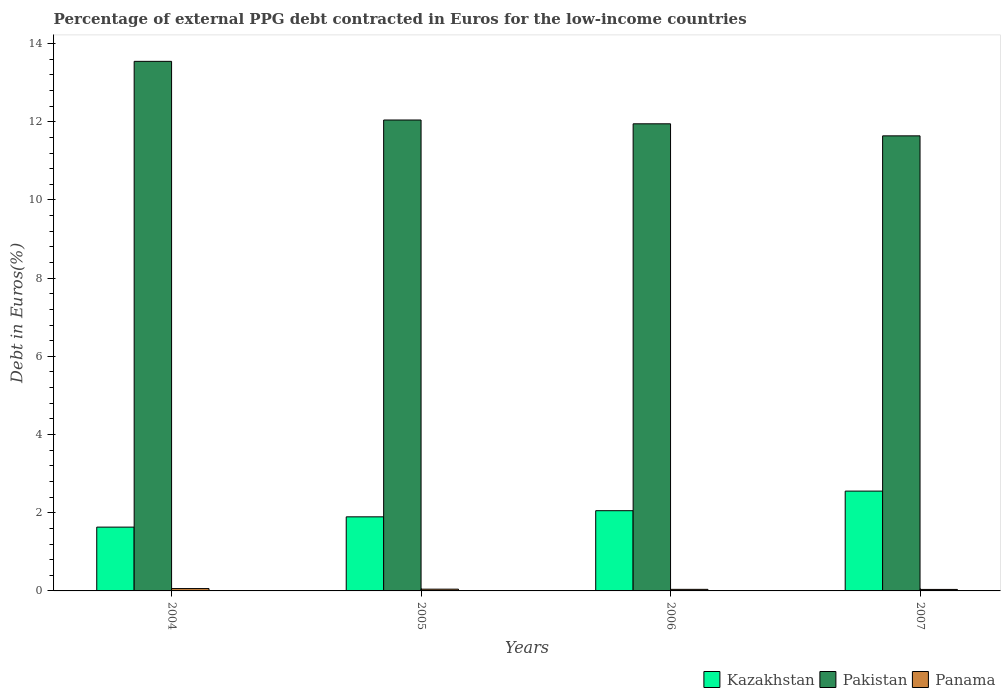How many groups of bars are there?
Provide a succinct answer. 4. Are the number of bars per tick equal to the number of legend labels?
Ensure brevity in your answer.  Yes. What is the label of the 4th group of bars from the left?
Keep it short and to the point. 2007. In how many cases, is the number of bars for a given year not equal to the number of legend labels?
Your answer should be very brief. 0. What is the percentage of external PPG debt contracted in Euros in Panama in 2004?
Your answer should be very brief. 0.06. Across all years, what is the maximum percentage of external PPG debt contracted in Euros in Panama?
Your response must be concise. 0.06. Across all years, what is the minimum percentage of external PPG debt contracted in Euros in Panama?
Provide a short and direct response. 0.04. What is the total percentage of external PPG debt contracted in Euros in Kazakhstan in the graph?
Keep it short and to the point. 8.13. What is the difference between the percentage of external PPG debt contracted in Euros in Kazakhstan in 2005 and that in 2006?
Offer a terse response. -0.16. What is the difference between the percentage of external PPG debt contracted in Euros in Panama in 2007 and the percentage of external PPG debt contracted in Euros in Kazakhstan in 2006?
Your response must be concise. -2.01. What is the average percentage of external PPG debt contracted in Euros in Kazakhstan per year?
Your response must be concise. 2.03. In the year 2005, what is the difference between the percentage of external PPG debt contracted in Euros in Kazakhstan and percentage of external PPG debt contracted in Euros in Pakistan?
Your response must be concise. -10.15. In how many years, is the percentage of external PPG debt contracted in Euros in Panama greater than 6.4 %?
Keep it short and to the point. 0. What is the ratio of the percentage of external PPG debt contracted in Euros in Panama in 2006 to that in 2007?
Offer a terse response. 1.05. What is the difference between the highest and the second highest percentage of external PPG debt contracted in Euros in Panama?
Give a very brief answer. 0.02. What is the difference between the highest and the lowest percentage of external PPG debt contracted in Euros in Kazakhstan?
Provide a short and direct response. 0.92. What does the 1st bar from the left in 2007 represents?
Ensure brevity in your answer.  Kazakhstan. What does the 3rd bar from the right in 2007 represents?
Provide a short and direct response. Kazakhstan. Are all the bars in the graph horizontal?
Ensure brevity in your answer.  No. How many years are there in the graph?
Ensure brevity in your answer.  4. Does the graph contain any zero values?
Your response must be concise. No. Where does the legend appear in the graph?
Your response must be concise. Bottom right. What is the title of the graph?
Your answer should be compact. Percentage of external PPG debt contracted in Euros for the low-income countries. What is the label or title of the Y-axis?
Your answer should be very brief. Debt in Euros(%). What is the Debt in Euros(%) in Kazakhstan in 2004?
Your answer should be compact. 1.63. What is the Debt in Euros(%) of Pakistan in 2004?
Provide a succinct answer. 13.54. What is the Debt in Euros(%) in Panama in 2004?
Make the answer very short. 0.06. What is the Debt in Euros(%) of Kazakhstan in 2005?
Ensure brevity in your answer.  1.89. What is the Debt in Euros(%) of Pakistan in 2005?
Ensure brevity in your answer.  12.04. What is the Debt in Euros(%) in Panama in 2005?
Offer a terse response. 0.04. What is the Debt in Euros(%) in Kazakhstan in 2006?
Provide a succinct answer. 2.05. What is the Debt in Euros(%) in Pakistan in 2006?
Your response must be concise. 11.95. What is the Debt in Euros(%) of Panama in 2006?
Ensure brevity in your answer.  0.04. What is the Debt in Euros(%) of Kazakhstan in 2007?
Provide a succinct answer. 2.55. What is the Debt in Euros(%) of Pakistan in 2007?
Give a very brief answer. 11.64. What is the Debt in Euros(%) of Panama in 2007?
Offer a terse response. 0.04. Across all years, what is the maximum Debt in Euros(%) in Kazakhstan?
Your response must be concise. 2.55. Across all years, what is the maximum Debt in Euros(%) in Pakistan?
Your answer should be compact. 13.54. Across all years, what is the maximum Debt in Euros(%) of Panama?
Ensure brevity in your answer.  0.06. Across all years, what is the minimum Debt in Euros(%) of Kazakhstan?
Provide a short and direct response. 1.63. Across all years, what is the minimum Debt in Euros(%) of Pakistan?
Provide a succinct answer. 11.64. Across all years, what is the minimum Debt in Euros(%) of Panama?
Make the answer very short. 0.04. What is the total Debt in Euros(%) of Kazakhstan in the graph?
Your answer should be compact. 8.13. What is the total Debt in Euros(%) in Pakistan in the graph?
Make the answer very short. 49.17. What is the total Debt in Euros(%) of Panama in the graph?
Your answer should be compact. 0.18. What is the difference between the Debt in Euros(%) of Kazakhstan in 2004 and that in 2005?
Provide a succinct answer. -0.26. What is the difference between the Debt in Euros(%) of Pakistan in 2004 and that in 2005?
Offer a terse response. 1.5. What is the difference between the Debt in Euros(%) in Panama in 2004 and that in 2005?
Make the answer very short. 0.02. What is the difference between the Debt in Euros(%) in Kazakhstan in 2004 and that in 2006?
Provide a succinct answer. -0.42. What is the difference between the Debt in Euros(%) of Pakistan in 2004 and that in 2006?
Offer a very short reply. 1.6. What is the difference between the Debt in Euros(%) in Panama in 2004 and that in 2006?
Offer a terse response. 0.02. What is the difference between the Debt in Euros(%) of Kazakhstan in 2004 and that in 2007?
Your answer should be very brief. -0.92. What is the difference between the Debt in Euros(%) in Pakistan in 2004 and that in 2007?
Provide a short and direct response. 1.91. What is the difference between the Debt in Euros(%) of Panama in 2004 and that in 2007?
Give a very brief answer. 0.02. What is the difference between the Debt in Euros(%) in Kazakhstan in 2005 and that in 2006?
Keep it short and to the point. -0.16. What is the difference between the Debt in Euros(%) in Pakistan in 2005 and that in 2006?
Your answer should be compact. 0.1. What is the difference between the Debt in Euros(%) of Panama in 2005 and that in 2006?
Provide a succinct answer. 0. What is the difference between the Debt in Euros(%) in Kazakhstan in 2005 and that in 2007?
Provide a short and direct response. -0.66. What is the difference between the Debt in Euros(%) in Pakistan in 2005 and that in 2007?
Provide a succinct answer. 0.41. What is the difference between the Debt in Euros(%) in Panama in 2005 and that in 2007?
Provide a short and direct response. 0.01. What is the difference between the Debt in Euros(%) of Kazakhstan in 2006 and that in 2007?
Offer a terse response. -0.5. What is the difference between the Debt in Euros(%) in Pakistan in 2006 and that in 2007?
Provide a succinct answer. 0.31. What is the difference between the Debt in Euros(%) in Panama in 2006 and that in 2007?
Make the answer very short. 0. What is the difference between the Debt in Euros(%) in Kazakhstan in 2004 and the Debt in Euros(%) in Pakistan in 2005?
Give a very brief answer. -10.41. What is the difference between the Debt in Euros(%) in Kazakhstan in 2004 and the Debt in Euros(%) in Panama in 2005?
Ensure brevity in your answer.  1.59. What is the difference between the Debt in Euros(%) in Pakistan in 2004 and the Debt in Euros(%) in Panama in 2005?
Your response must be concise. 13.5. What is the difference between the Debt in Euros(%) of Kazakhstan in 2004 and the Debt in Euros(%) of Pakistan in 2006?
Give a very brief answer. -10.32. What is the difference between the Debt in Euros(%) in Kazakhstan in 2004 and the Debt in Euros(%) in Panama in 2006?
Your answer should be very brief. 1.59. What is the difference between the Debt in Euros(%) of Pakistan in 2004 and the Debt in Euros(%) of Panama in 2006?
Your response must be concise. 13.5. What is the difference between the Debt in Euros(%) in Kazakhstan in 2004 and the Debt in Euros(%) in Pakistan in 2007?
Provide a short and direct response. -10.01. What is the difference between the Debt in Euros(%) in Kazakhstan in 2004 and the Debt in Euros(%) in Panama in 2007?
Give a very brief answer. 1.59. What is the difference between the Debt in Euros(%) of Pakistan in 2004 and the Debt in Euros(%) of Panama in 2007?
Your answer should be compact. 13.51. What is the difference between the Debt in Euros(%) of Kazakhstan in 2005 and the Debt in Euros(%) of Pakistan in 2006?
Your answer should be very brief. -10.05. What is the difference between the Debt in Euros(%) in Kazakhstan in 2005 and the Debt in Euros(%) in Panama in 2006?
Give a very brief answer. 1.85. What is the difference between the Debt in Euros(%) in Pakistan in 2005 and the Debt in Euros(%) in Panama in 2006?
Provide a succinct answer. 12. What is the difference between the Debt in Euros(%) in Kazakhstan in 2005 and the Debt in Euros(%) in Pakistan in 2007?
Your answer should be very brief. -9.74. What is the difference between the Debt in Euros(%) of Kazakhstan in 2005 and the Debt in Euros(%) of Panama in 2007?
Ensure brevity in your answer.  1.86. What is the difference between the Debt in Euros(%) of Pakistan in 2005 and the Debt in Euros(%) of Panama in 2007?
Keep it short and to the point. 12.01. What is the difference between the Debt in Euros(%) of Kazakhstan in 2006 and the Debt in Euros(%) of Pakistan in 2007?
Your response must be concise. -9.59. What is the difference between the Debt in Euros(%) in Kazakhstan in 2006 and the Debt in Euros(%) in Panama in 2007?
Offer a terse response. 2.01. What is the difference between the Debt in Euros(%) in Pakistan in 2006 and the Debt in Euros(%) in Panama in 2007?
Your answer should be very brief. 11.91. What is the average Debt in Euros(%) of Kazakhstan per year?
Give a very brief answer. 2.03. What is the average Debt in Euros(%) in Pakistan per year?
Offer a very short reply. 12.29. What is the average Debt in Euros(%) of Panama per year?
Provide a succinct answer. 0.05. In the year 2004, what is the difference between the Debt in Euros(%) of Kazakhstan and Debt in Euros(%) of Pakistan?
Ensure brevity in your answer.  -11.91. In the year 2004, what is the difference between the Debt in Euros(%) of Kazakhstan and Debt in Euros(%) of Panama?
Ensure brevity in your answer.  1.57. In the year 2004, what is the difference between the Debt in Euros(%) in Pakistan and Debt in Euros(%) in Panama?
Ensure brevity in your answer.  13.48. In the year 2005, what is the difference between the Debt in Euros(%) in Kazakhstan and Debt in Euros(%) in Pakistan?
Ensure brevity in your answer.  -10.15. In the year 2005, what is the difference between the Debt in Euros(%) of Kazakhstan and Debt in Euros(%) of Panama?
Provide a short and direct response. 1.85. In the year 2005, what is the difference between the Debt in Euros(%) of Pakistan and Debt in Euros(%) of Panama?
Provide a short and direct response. 12. In the year 2006, what is the difference between the Debt in Euros(%) of Kazakhstan and Debt in Euros(%) of Pakistan?
Make the answer very short. -9.9. In the year 2006, what is the difference between the Debt in Euros(%) of Kazakhstan and Debt in Euros(%) of Panama?
Offer a terse response. 2.01. In the year 2006, what is the difference between the Debt in Euros(%) in Pakistan and Debt in Euros(%) in Panama?
Offer a very short reply. 11.91. In the year 2007, what is the difference between the Debt in Euros(%) of Kazakhstan and Debt in Euros(%) of Pakistan?
Provide a succinct answer. -9.09. In the year 2007, what is the difference between the Debt in Euros(%) of Kazakhstan and Debt in Euros(%) of Panama?
Provide a succinct answer. 2.51. In the year 2007, what is the difference between the Debt in Euros(%) of Pakistan and Debt in Euros(%) of Panama?
Offer a very short reply. 11.6. What is the ratio of the Debt in Euros(%) of Kazakhstan in 2004 to that in 2005?
Make the answer very short. 0.86. What is the ratio of the Debt in Euros(%) in Pakistan in 2004 to that in 2005?
Provide a short and direct response. 1.12. What is the ratio of the Debt in Euros(%) in Panama in 2004 to that in 2005?
Give a very brief answer. 1.34. What is the ratio of the Debt in Euros(%) in Kazakhstan in 2004 to that in 2006?
Give a very brief answer. 0.8. What is the ratio of the Debt in Euros(%) of Pakistan in 2004 to that in 2006?
Provide a short and direct response. 1.13. What is the ratio of the Debt in Euros(%) of Panama in 2004 to that in 2006?
Offer a very short reply. 1.5. What is the ratio of the Debt in Euros(%) of Kazakhstan in 2004 to that in 2007?
Give a very brief answer. 0.64. What is the ratio of the Debt in Euros(%) in Pakistan in 2004 to that in 2007?
Provide a short and direct response. 1.16. What is the ratio of the Debt in Euros(%) of Panama in 2004 to that in 2007?
Offer a terse response. 1.57. What is the ratio of the Debt in Euros(%) of Kazakhstan in 2005 to that in 2006?
Your response must be concise. 0.92. What is the ratio of the Debt in Euros(%) in Pakistan in 2005 to that in 2006?
Give a very brief answer. 1.01. What is the ratio of the Debt in Euros(%) of Panama in 2005 to that in 2006?
Offer a terse response. 1.12. What is the ratio of the Debt in Euros(%) in Kazakhstan in 2005 to that in 2007?
Provide a short and direct response. 0.74. What is the ratio of the Debt in Euros(%) in Pakistan in 2005 to that in 2007?
Ensure brevity in your answer.  1.03. What is the ratio of the Debt in Euros(%) of Panama in 2005 to that in 2007?
Make the answer very short. 1.17. What is the ratio of the Debt in Euros(%) of Kazakhstan in 2006 to that in 2007?
Give a very brief answer. 0.8. What is the ratio of the Debt in Euros(%) of Pakistan in 2006 to that in 2007?
Ensure brevity in your answer.  1.03. What is the ratio of the Debt in Euros(%) in Panama in 2006 to that in 2007?
Provide a succinct answer. 1.05. What is the difference between the highest and the second highest Debt in Euros(%) of Kazakhstan?
Offer a very short reply. 0.5. What is the difference between the highest and the second highest Debt in Euros(%) of Pakistan?
Your answer should be very brief. 1.5. What is the difference between the highest and the second highest Debt in Euros(%) in Panama?
Your answer should be very brief. 0.02. What is the difference between the highest and the lowest Debt in Euros(%) of Kazakhstan?
Keep it short and to the point. 0.92. What is the difference between the highest and the lowest Debt in Euros(%) in Pakistan?
Your response must be concise. 1.91. What is the difference between the highest and the lowest Debt in Euros(%) in Panama?
Make the answer very short. 0.02. 